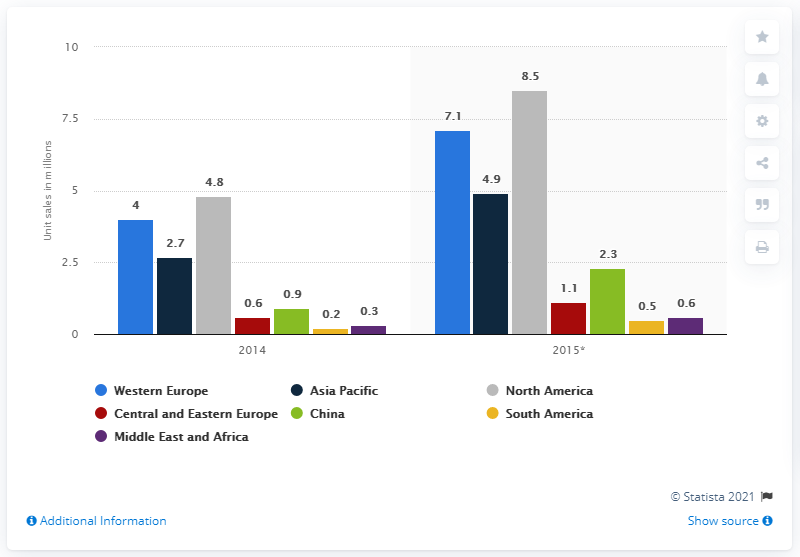Point out several critical features in this image. According to the forecast, the unit sales of health and fitness trackers in Western Europe in 2015 were 7.1. 